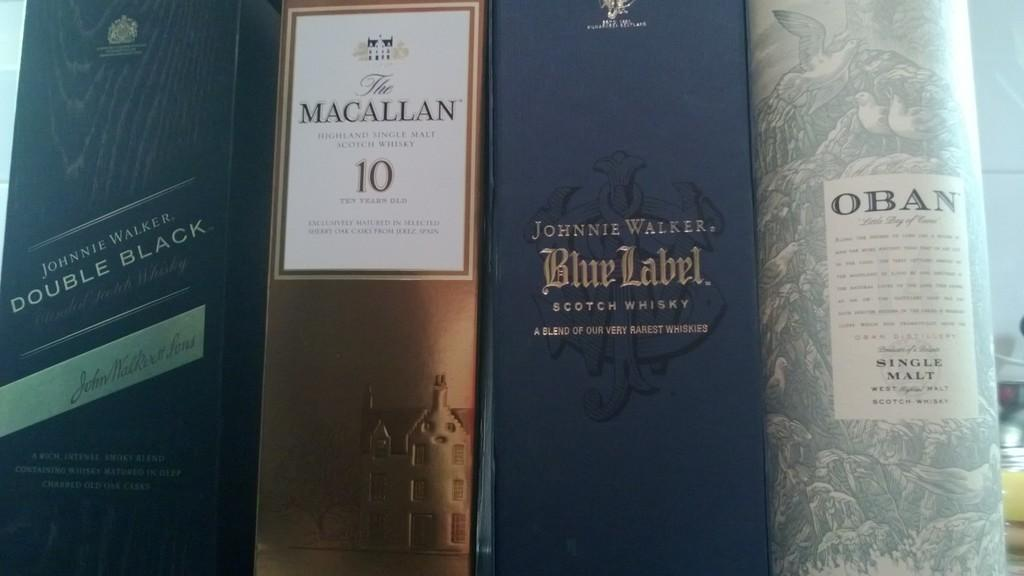<image>
Offer a succinct explanation of the picture presented. A set of books sitting side by side with names like Macallan, Blue Label and Oban, 